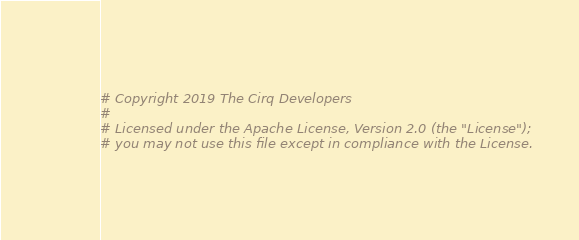<code> <loc_0><loc_0><loc_500><loc_500><_Python_># Copyright 2019 The Cirq Developers
#
# Licensed under the Apache License, Version 2.0 (the "License");
# you may not use this file except in compliance with the License.</code> 